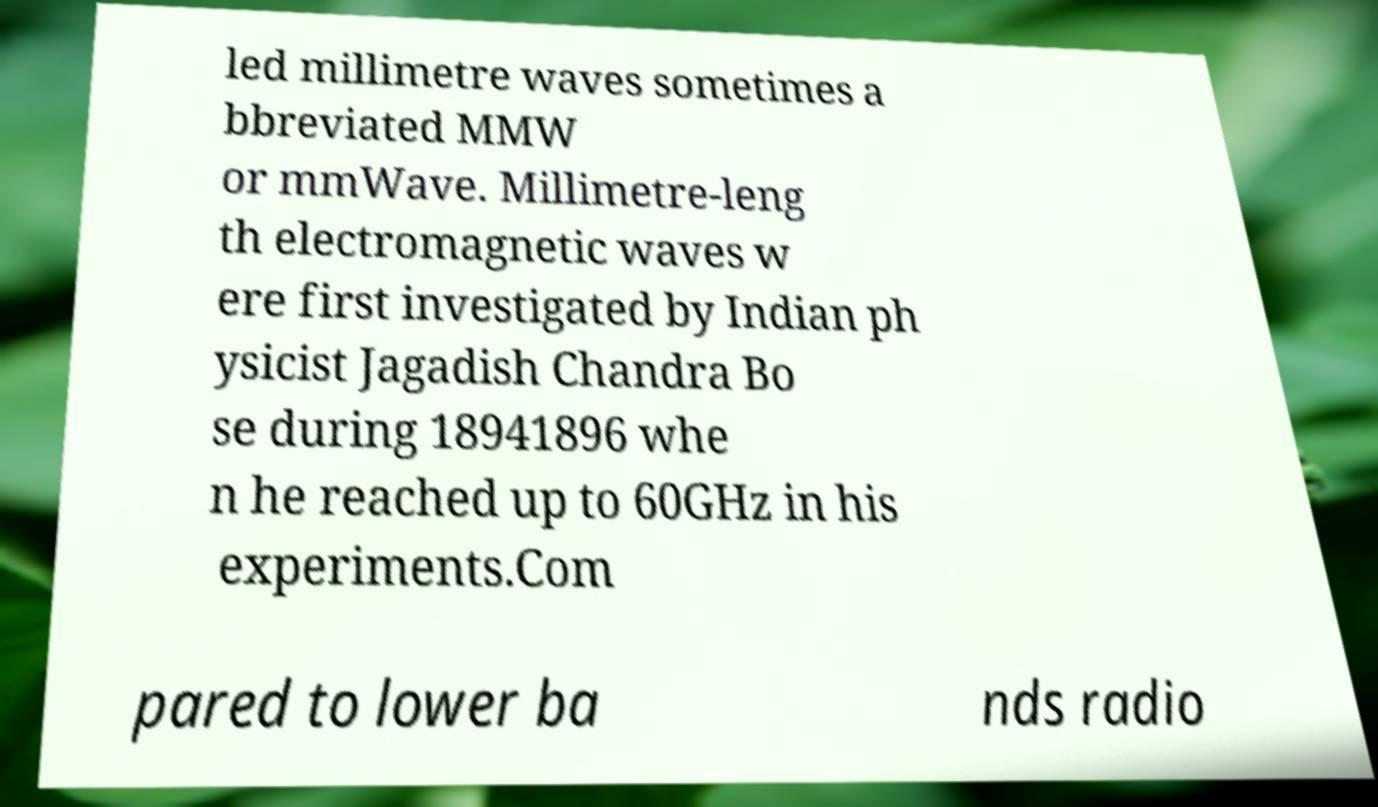Could you assist in decoding the text presented in this image and type it out clearly? led millimetre waves sometimes a bbreviated MMW or mmWave. Millimetre-leng th electromagnetic waves w ere first investigated by Indian ph ysicist Jagadish Chandra Bo se during 18941896 whe n he reached up to 60GHz in his experiments.Com pared to lower ba nds radio 